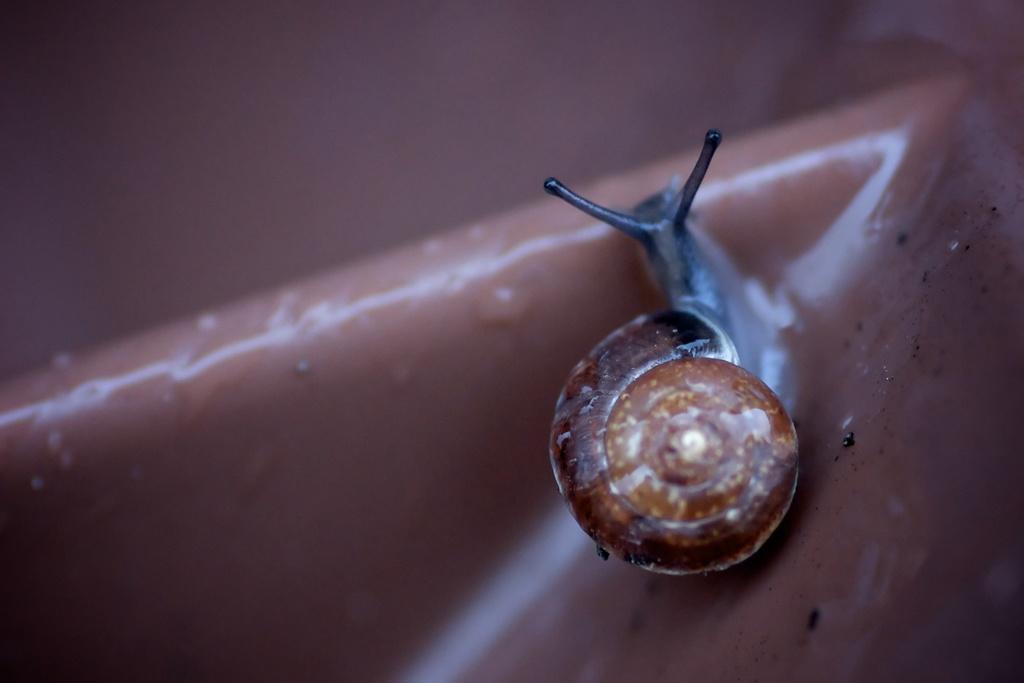Describe this image in one or two sentences. In this picture we can see one insert. 